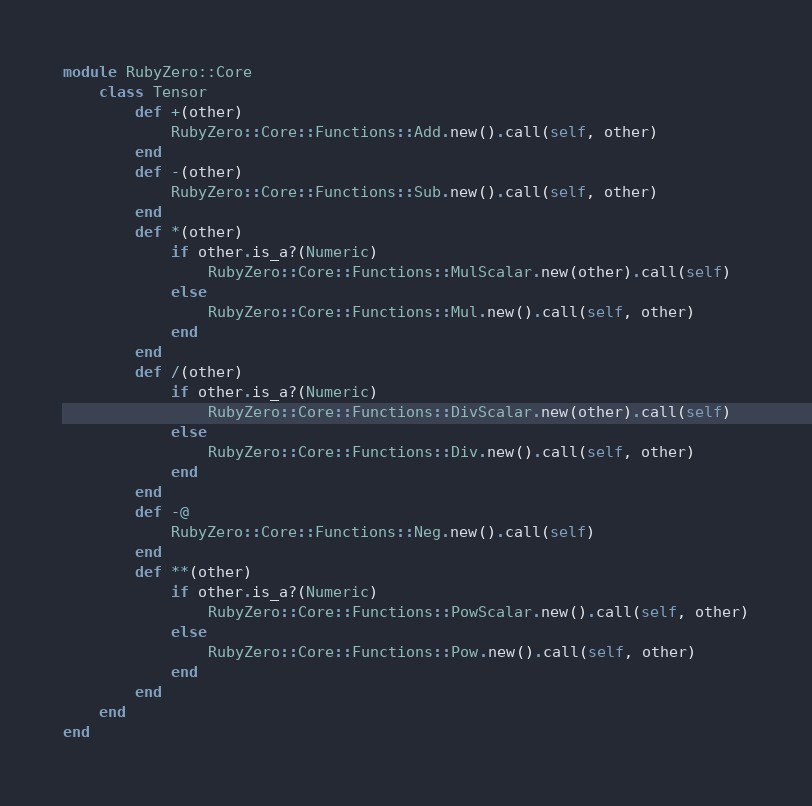Convert code to text. <code><loc_0><loc_0><loc_500><loc_500><_Ruby_>module RubyZero::Core
    class Tensor
        def +(other)
            RubyZero::Core::Functions::Add.new().call(self, other)
        end
        def -(other)
            RubyZero::Core::Functions::Sub.new().call(self, other)
        end
        def *(other)
            if other.is_a?(Numeric)
                RubyZero::Core::Functions::MulScalar.new(other).call(self)
            else
                RubyZero::Core::Functions::Mul.new().call(self, other)
            end
        end
        def /(other)
            if other.is_a?(Numeric)
                RubyZero::Core::Functions::DivScalar.new(other).call(self)
            else
                RubyZero::Core::Functions::Div.new().call(self, other)
            end
        end
        def -@
            RubyZero::Core::Functions::Neg.new().call(self)
        end
        def **(other)
            if other.is_a?(Numeric)
                RubyZero::Core::Functions::PowScalar.new().call(self, other)
            else
                RubyZero::Core::Functions::Pow.new().call(self, other)
            end
        end
    end
end</code> 